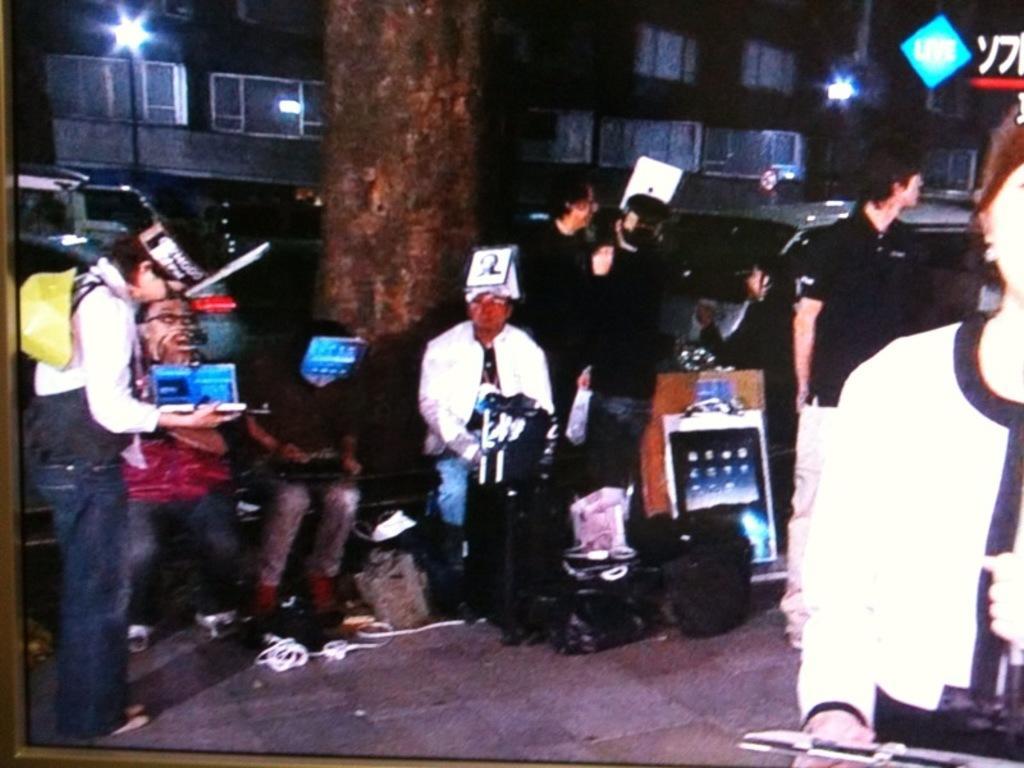Can you describe this image briefly? This is clicked in a street, there are many people standing with tablets in their hands on the foot path in front of a tree and behind there are vehicles going on the road, over the background there is a building. 